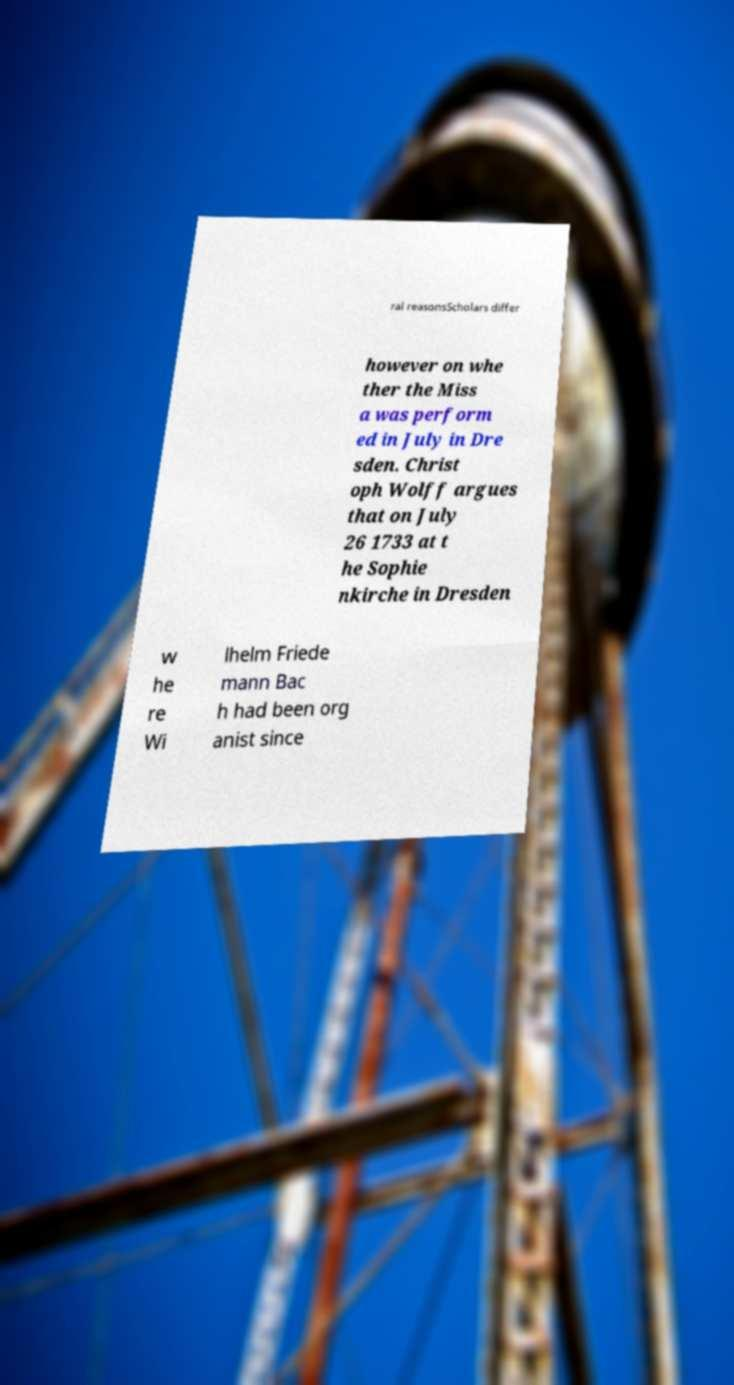Can you accurately transcribe the text from the provided image for me? ral reasonsScholars differ however on whe ther the Miss a was perform ed in July in Dre sden. Christ oph Wolff argues that on July 26 1733 at t he Sophie nkirche in Dresden w he re Wi lhelm Friede mann Bac h had been org anist since 